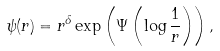<formula> <loc_0><loc_0><loc_500><loc_500>\psi ( r ) = r ^ { \delta } \exp \left ( \Psi \left ( \log \frac { 1 } { r } \right ) \right ) ,</formula> 